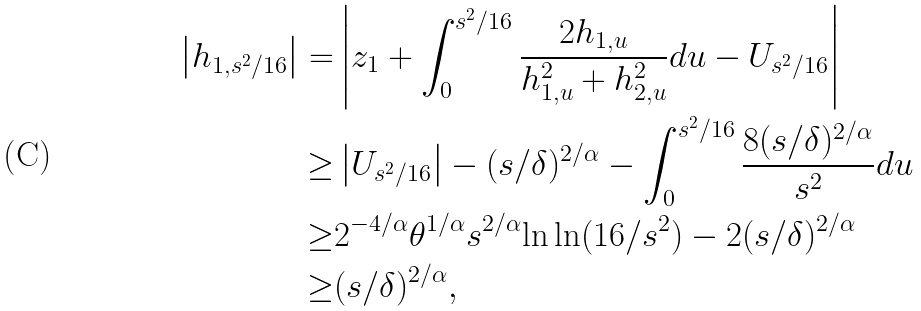<formula> <loc_0><loc_0><loc_500><loc_500>\left | h _ { 1 , s ^ { 2 } / 1 6 } \right | = & \left | z _ { 1 } + \int _ { 0 } ^ { s ^ { 2 } / 1 6 } \frac { 2 h _ { 1 , u } } { h _ { 1 , u } ^ { 2 } + h _ { 2 , u } ^ { 2 } } d u - U _ { s ^ { 2 } / 1 6 } \right | \\ \geq & \left | U _ { s ^ { 2 } / 1 6 } \right | - ( s / \delta ) ^ { 2 / \alpha } - \int _ { 0 } ^ { s ^ { 2 } / 1 6 } \frac { 8 ( s / \delta ) ^ { 2 / \alpha } } { s ^ { 2 } } d u \\ \geq & 2 ^ { - 4 / \alpha } \theta ^ { 1 / \alpha } s ^ { 2 / \alpha } { \ln \ln ( 1 6 / s ^ { 2 } ) } - 2 ( s / \delta ) ^ { 2 / \alpha } \\ \geq & ( s / \delta ) ^ { 2 / \alpha } ,</formula> 